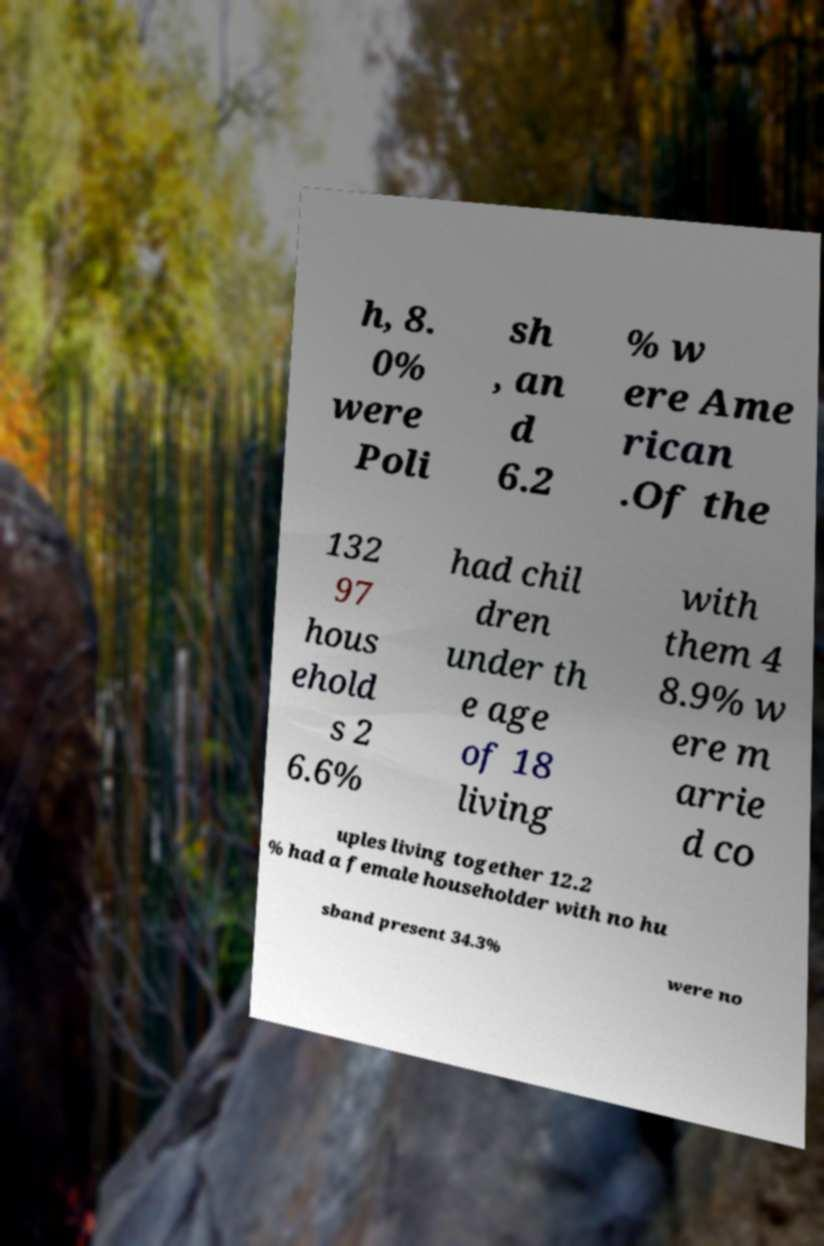Please identify and transcribe the text found in this image. h, 8. 0% were Poli sh , an d 6.2 % w ere Ame rican .Of the 132 97 hous ehold s 2 6.6% had chil dren under th e age of 18 living with them 4 8.9% w ere m arrie d co uples living together 12.2 % had a female householder with no hu sband present 34.3% were no 